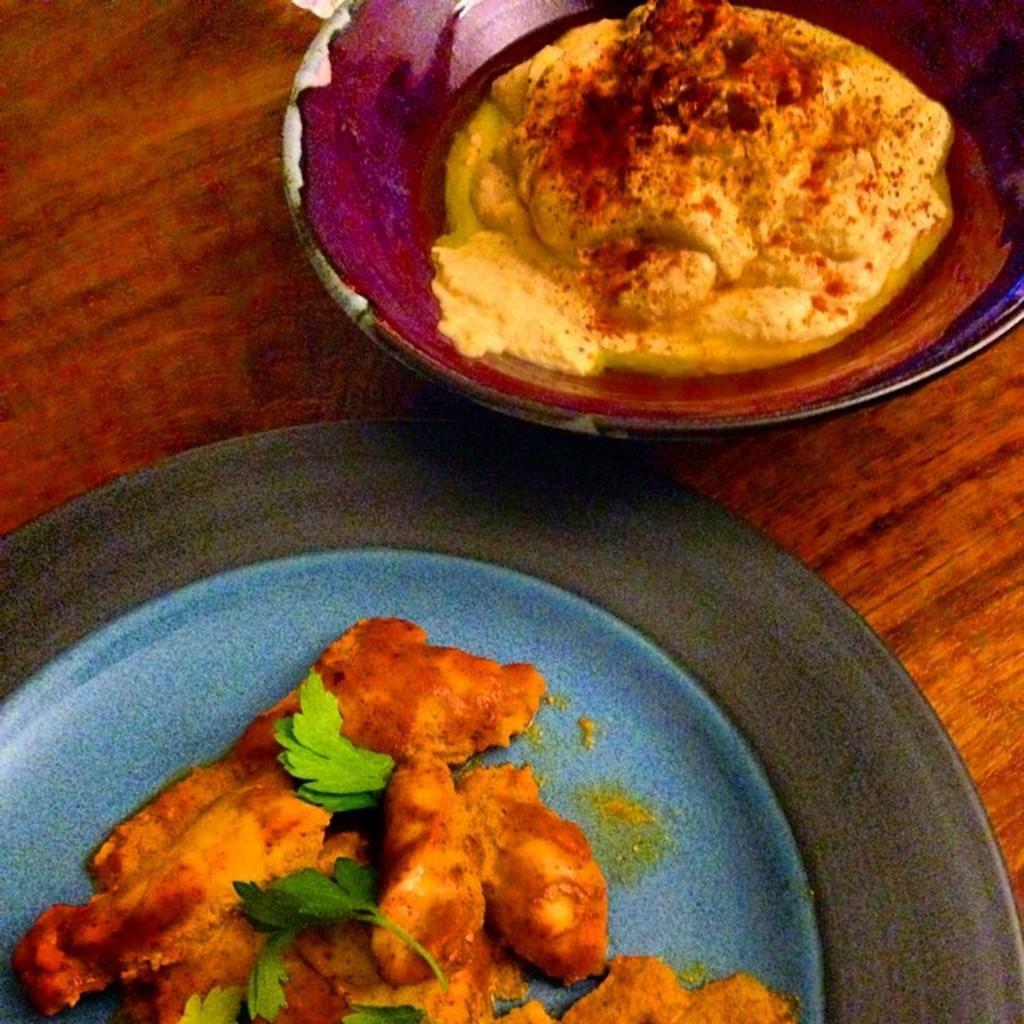Please provide a concise description of this image. In this picture there are different food items on the plate and in the bowl. At the bottom it looks like a table. 